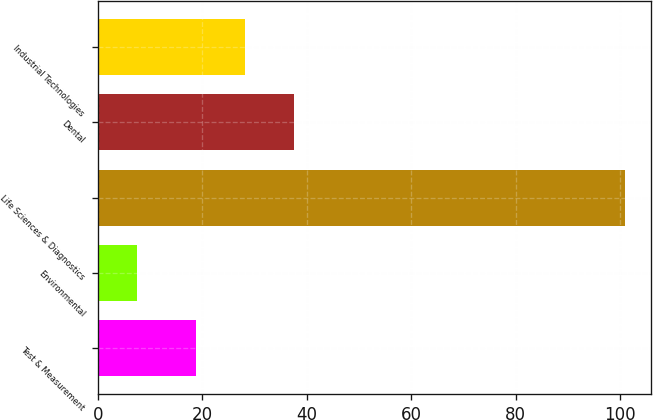Convert chart. <chart><loc_0><loc_0><loc_500><loc_500><bar_chart><fcel>Test & Measurement<fcel>Environmental<fcel>Life Sciences & Diagnostics<fcel>Dental<fcel>Industrial Technologies<nl><fcel>18.8<fcel>7.5<fcel>100.9<fcel>37.48<fcel>28.14<nl></chart> 